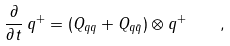Convert formula to latex. <formula><loc_0><loc_0><loc_500><loc_500>\frac { \partial } { \partial t } \, q ^ { + } = ( Q _ { q q } + Q _ { q \bar { q } } ) \otimes q ^ { + } \quad ,</formula> 